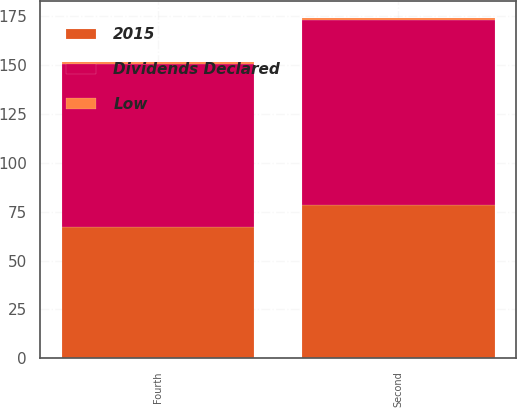<chart> <loc_0><loc_0><loc_500><loc_500><stacked_bar_chart><ecel><fcel>Second<fcel>Fourth<nl><fcel>Dividends Declared<fcel>94.88<fcel>83.42<nl><fcel>2015<fcel>78.29<fcel>67.12<nl><fcel>Low<fcel>0.82<fcel>0.92<nl></chart> 